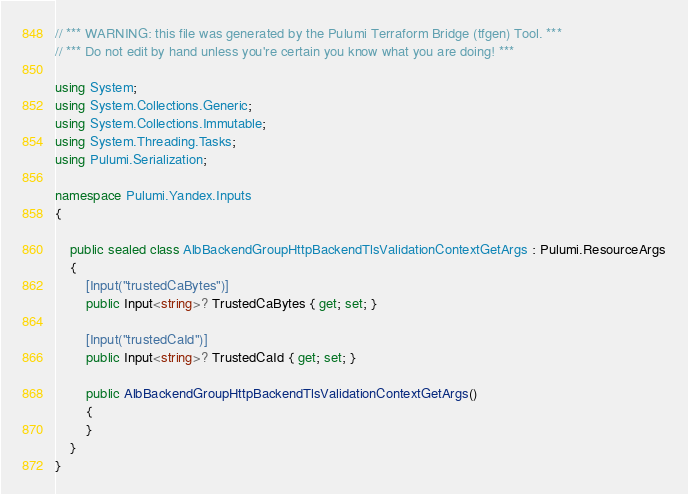Convert code to text. <code><loc_0><loc_0><loc_500><loc_500><_C#_>// *** WARNING: this file was generated by the Pulumi Terraform Bridge (tfgen) Tool. ***
// *** Do not edit by hand unless you're certain you know what you are doing! ***

using System;
using System.Collections.Generic;
using System.Collections.Immutable;
using System.Threading.Tasks;
using Pulumi.Serialization;

namespace Pulumi.Yandex.Inputs
{

    public sealed class AlbBackendGroupHttpBackendTlsValidationContextGetArgs : Pulumi.ResourceArgs
    {
        [Input("trustedCaBytes")]
        public Input<string>? TrustedCaBytes { get; set; }

        [Input("trustedCaId")]
        public Input<string>? TrustedCaId { get; set; }

        public AlbBackendGroupHttpBackendTlsValidationContextGetArgs()
        {
        }
    }
}
</code> 